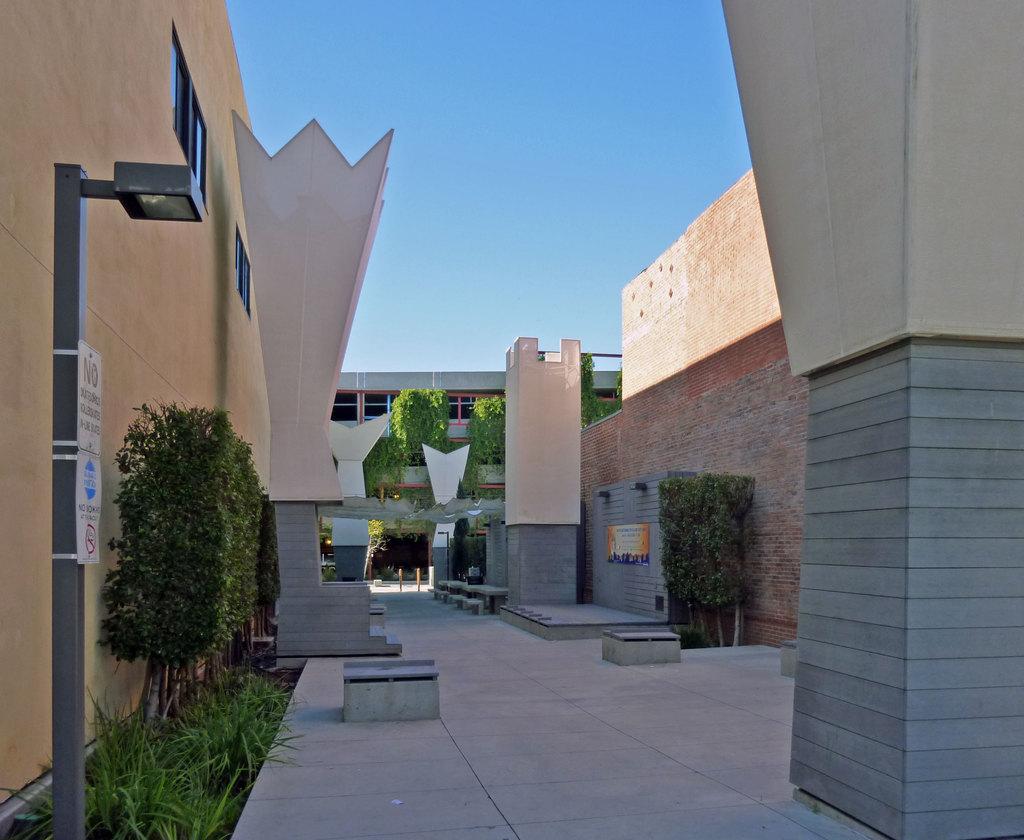What does the left sign say?
Ensure brevity in your answer.  Unanswerable. 